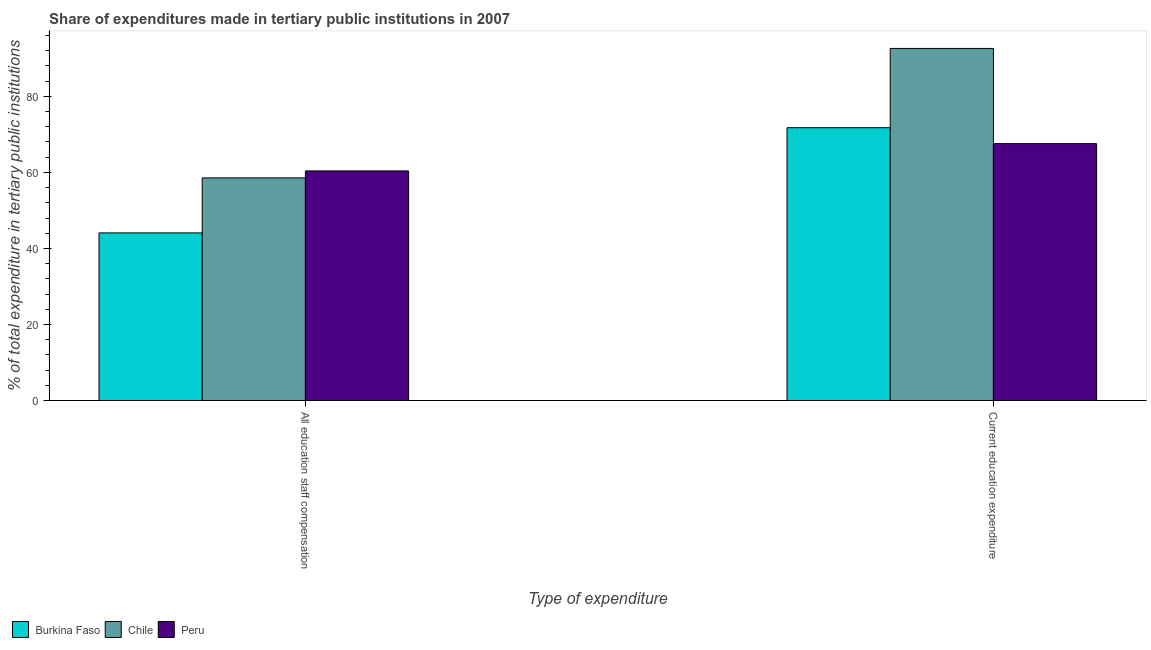Are the number of bars on each tick of the X-axis equal?
Provide a succinct answer. Yes. How many bars are there on the 1st tick from the right?
Offer a very short reply. 3. What is the label of the 1st group of bars from the left?
Keep it short and to the point. All education staff compensation. What is the expenditure in staff compensation in Chile?
Offer a terse response. 58.56. Across all countries, what is the maximum expenditure in staff compensation?
Your answer should be compact. 60.39. Across all countries, what is the minimum expenditure in education?
Keep it short and to the point. 67.57. In which country was the expenditure in education minimum?
Provide a short and direct response. Peru. What is the total expenditure in education in the graph?
Your answer should be compact. 231.91. What is the difference between the expenditure in staff compensation in Chile and that in Peru?
Offer a very short reply. -1.83. What is the difference between the expenditure in staff compensation in Peru and the expenditure in education in Burkina Faso?
Offer a terse response. -11.36. What is the average expenditure in education per country?
Offer a very short reply. 77.3. What is the difference between the expenditure in education and expenditure in staff compensation in Peru?
Provide a succinct answer. 7.18. In how many countries, is the expenditure in education greater than 20 %?
Ensure brevity in your answer.  3. What is the ratio of the expenditure in education in Chile to that in Burkina Faso?
Your answer should be very brief. 1.29. What does the 2nd bar from the right in Current education expenditure represents?
Give a very brief answer. Chile. How many countries are there in the graph?
Your answer should be compact. 3. What is the difference between two consecutive major ticks on the Y-axis?
Keep it short and to the point. 20. Are the values on the major ticks of Y-axis written in scientific E-notation?
Give a very brief answer. No. Does the graph contain grids?
Your answer should be compact. No. Where does the legend appear in the graph?
Your response must be concise. Bottom left. What is the title of the graph?
Provide a short and direct response. Share of expenditures made in tertiary public institutions in 2007. Does "Somalia" appear as one of the legend labels in the graph?
Offer a very short reply. No. What is the label or title of the X-axis?
Provide a short and direct response. Type of expenditure. What is the label or title of the Y-axis?
Make the answer very short. % of total expenditure in tertiary public institutions. What is the % of total expenditure in tertiary public institutions of Burkina Faso in All education staff compensation?
Ensure brevity in your answer.  44.09. What is the % of total expenditure in tertiary public institutions of Chile in All education staff compensation?
Your answer should be very brief. 58.56. What is the % of total expenditure in tertiary public institutions of Peru in All education staff compensation?
Make the answer very short. 60.39. What is the % of total expenditure in tertiary public institutions in Burkina Faso in Current education expenditure?
Make the answer very short. 71.75. What is the % of total expenditure in tertiary public institutions of Chile in Current education expenditure?
Keep it short and to the point. 92.6. What is the % of total expenditure in tertiary public institutions in Peru in Current education expenditure?
Offer a terse response. 67.57. Across all Type of expenditure, what is the maximum % of total expenditure in tertiary public institutions of Burkina Faso?
Ensure brevity in your answer.  71.75. Across all Type of expenditure, what is the maximum % of total expenditure in tertiary public institutions in Chile?
Offer a terse response. 92.6. Across all Type of expenditure, what is the maximum % of total expenditure in tertiary public institutions of Peru?
Keep it short and to the point. 67.57. Across all Type of expenditure, what is the minimum % of total expenditure in tertiary public institutions of Burkina Faso?
Offer a very short reply. 44.09. Across all Type of expenditure, what is the minimum % of total expenditure in tertiary public institutions of Chile?
Your answer should be compact. 58.56. Across all Type of expenditure, what is the minimum % of total expenditure in tertiary public institutions of Peru?
Keep it short and to the point. 60.39. What is the total % of total expenditure in tertiary public institutions of Burkina Faso in the graph?
Ensure brevity in your answer.  115.84. What is the total % of total expenditure in tertiary public institutions of Chile in the graph?
Give a very brief answer. 151.15. What is the total % of total expenditure in tertiary public institutions in Peru in the graph?
Give a very brief answer. 127.96. What is the difference between the % of total expenditure in tertiary public institutions of Burkina Faso in All education staff compensation and that in Current education expenditure?
Give a very brief answer. -27.66. What is the difference between the % of total expenditure in tertiary public institutions of Chile in All education staff compensation and that in Current education expenditure?
Keep it short and to the point. -34.04. What is the difference between the % of total expenditure in tertiary public institutions in Peru in All education staff compensation and that in Current education expenditure?
Your response must be concise. -7.18. What is the difference between the % of total expenditure in tertiary public institutions of Burkina Faso in All education staff compensation and the % of total expenditure in tertiary public institutions of Chile in Current education expenditure?
Provide a short and direct response. -48.51. What is the difference between the % of total expenditure in tertiary public institutions in Burkina Faso in All education staff compensation and the % of total expenditure in tertiary public institutions in Peru in Current education expenditure?
Keep it short and to the point. -23.48. What is the difference between the % of total expenditure in tertiary public institutions of Chile in All education staff compensation and the % of total expenditure in tertiary public institutions of Peru in Current education expenditure?
Keep it short and to the point. -9.01. What is the average % of total expenditure in tertiary public institutions in Burkina Faso per Type of expenditure?
Your response must be concise. 57.92. What is the average % of total expenditure in tertiary public institutions of Chile per Type of expenditure?
Your answer should be very brief. 75.58. What is the average % of total expenditure in tertiary public institutions in Peru per Type of expenditure?
Keep it short and to the point. 63.98. What is the difference between the % of total expenditure in tertiary public institutions in Burkina Faso and % of total expenditure in tertiary public institutions in Chile in All education staff compensation?
Make the answer very short. -14.46. What is the difference between the % of total expenditure in tertiary public institutions in Burkina Faso and % of total expenditure in tertiary public institutions in Peru in All education staff compensation?
Give a very brief answer. -16.3. What is the difference between the % of total expenditure in tertiary public institutions of Chile and % of total expenditure in tertiary public institutions of Peru in All education staff compensation?
Your answer should be very brief. -1.83. What is the difference between the % of total expenditure in tertiary public institutions in Burkina Faso and % of total expenditure in tertiary public institutions in Chile in Current education expenditure?
Your answer should be very brief. -20.85. What is the difference between the % of total expenditure in tertiary public institutions in Burkina Faso and % of total expenditure in tertiary public institutions in Peru in Current education expenditure?
Your response must be concise. 4.18. What is the difference between the % of total expenditure in tertiary public institutions in Chile and % of total expenditure in tertiary public institutions in Peru in Current education expenditure?
Provide a short and direct response. 25.03. What is the ratio of the % of total expenditure in tertiary public institutions in Burkina Faso in All education staff compensation to that in Current education expenditure?
Offer a terse response. 0.61. What is the ratio of the % of total expenditure in tertiary public institutions of Chile in All education staff compensation to that in Current education expenditure?
Offer a terse response. 0.63. What is the ratio of the % of total expenditure in tertiary public institutions of Peru in All education staff compensation to that in Current education expenditure?
Give a very brief answer. 0.89. What is the difference between the highest and the second highest % of total expenditure in tertiary public institutions of Burkina Faso?
Your response must be concise. 27.66. What is the difference between the highest and the second highest % of total expenditure in tertiary public institutions of Chile?
Your answer should be very brief. 34.04. What is the difference between the highest and the second highest % of total expenditure in tertiary public institutions of Peru?
Your response must be concise. 7.18. What is the difference between the highest and the lowest % of total expenditure in tertiary public institutions in Burkina Faso?
Your answer should be compact. 27.66. What is the difference between the highest and the lowest % of total expenditure in tertiary public institutions of Chile?
Ensure brevity in your answer.  34.04. What is the difference between the highest and the lowest % of total expenditure in tertiary public institutions of Peru?
Provide a short and direct response. 7.18. 